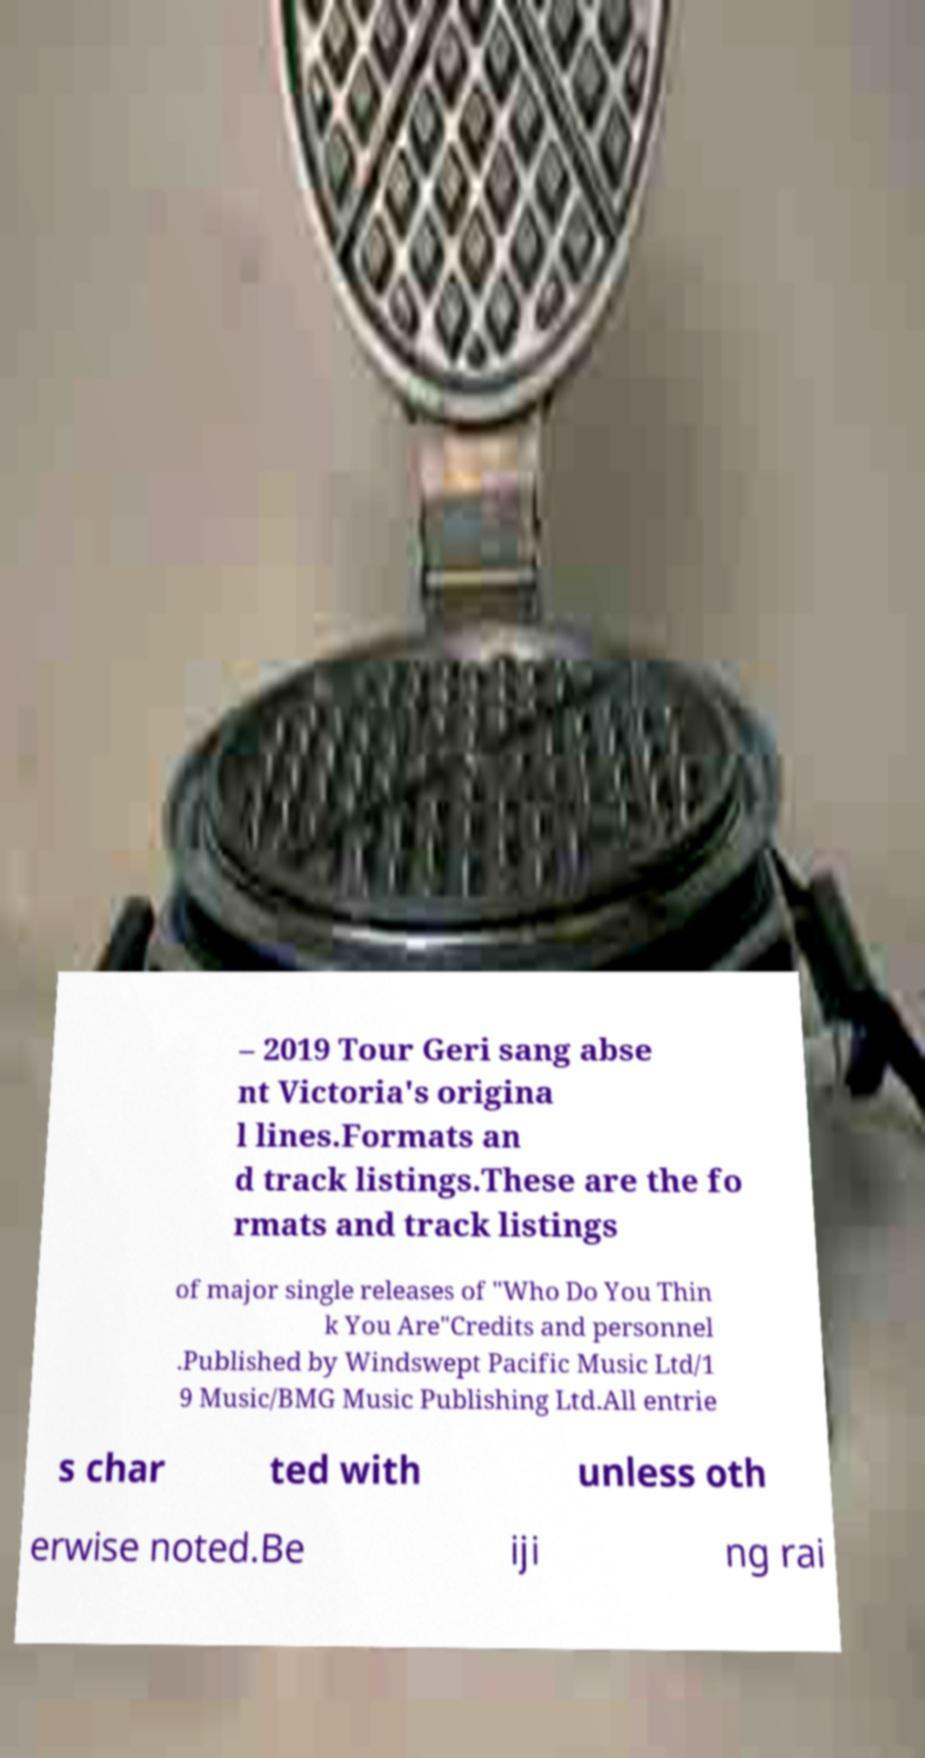Please identify and transcribe the text found in this image. – 2019 Tour Geri sang abse nt Victoria's origina l lines.Formats an d track listings.These are the fo rmats and track listings of major single releases of "Who Do You Thin k You Are"Credits and personnel .Published by Windswept Pacific Music Ltd/1 9 Music/BMG Music Publishing Ltd.All entrie s char ted with unless oth erwise noted.Be iji ng rai 